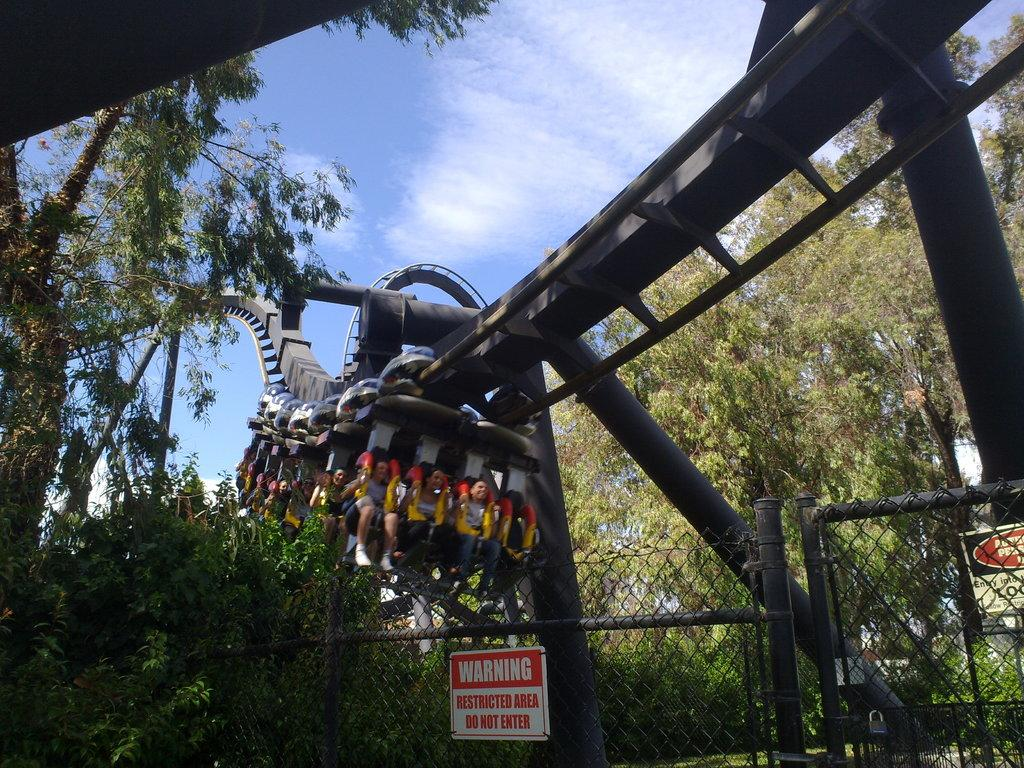What activity are the people in the image participating in? The people in the image are riding a roller coaster. What can be seen near the roller coaster in the image? There is a fence and caution boards present in the image. What is visible in the background of the image? There are trees and the sky in the background of the image. Can you describe the sky in the image? The sky is blue with clouds in the background. What type of good-bye message is written on the swing in the image? There is no swing present in the image, and therefore no good-bye message can be observed. 